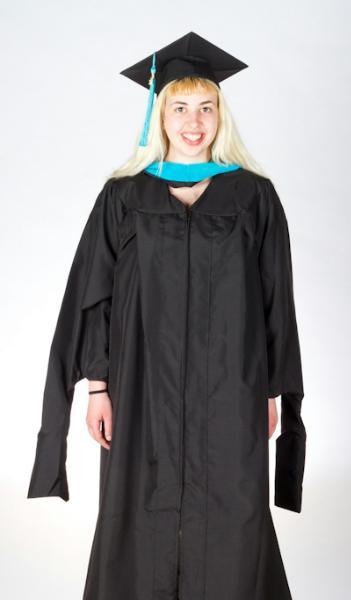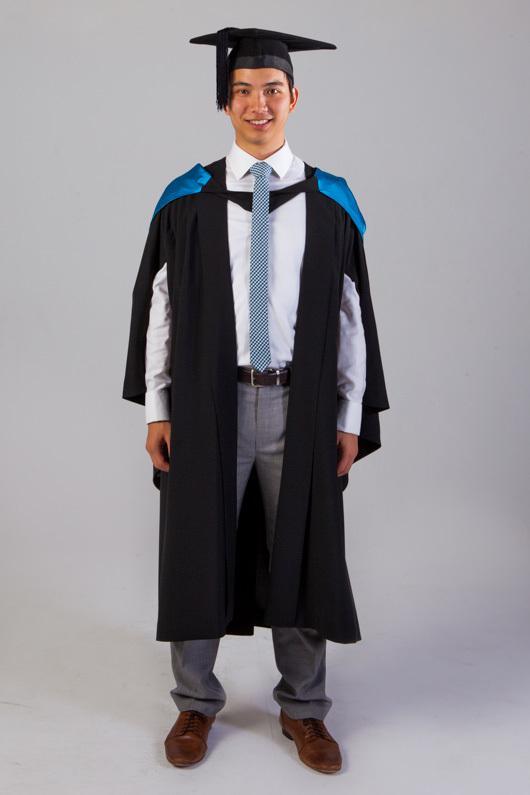The first image is the image on the left, the second image is the image on the right. Analyze the images presented: Is the assertion "There is a woman in the image on the right." valid? Answer yes or no. No. 